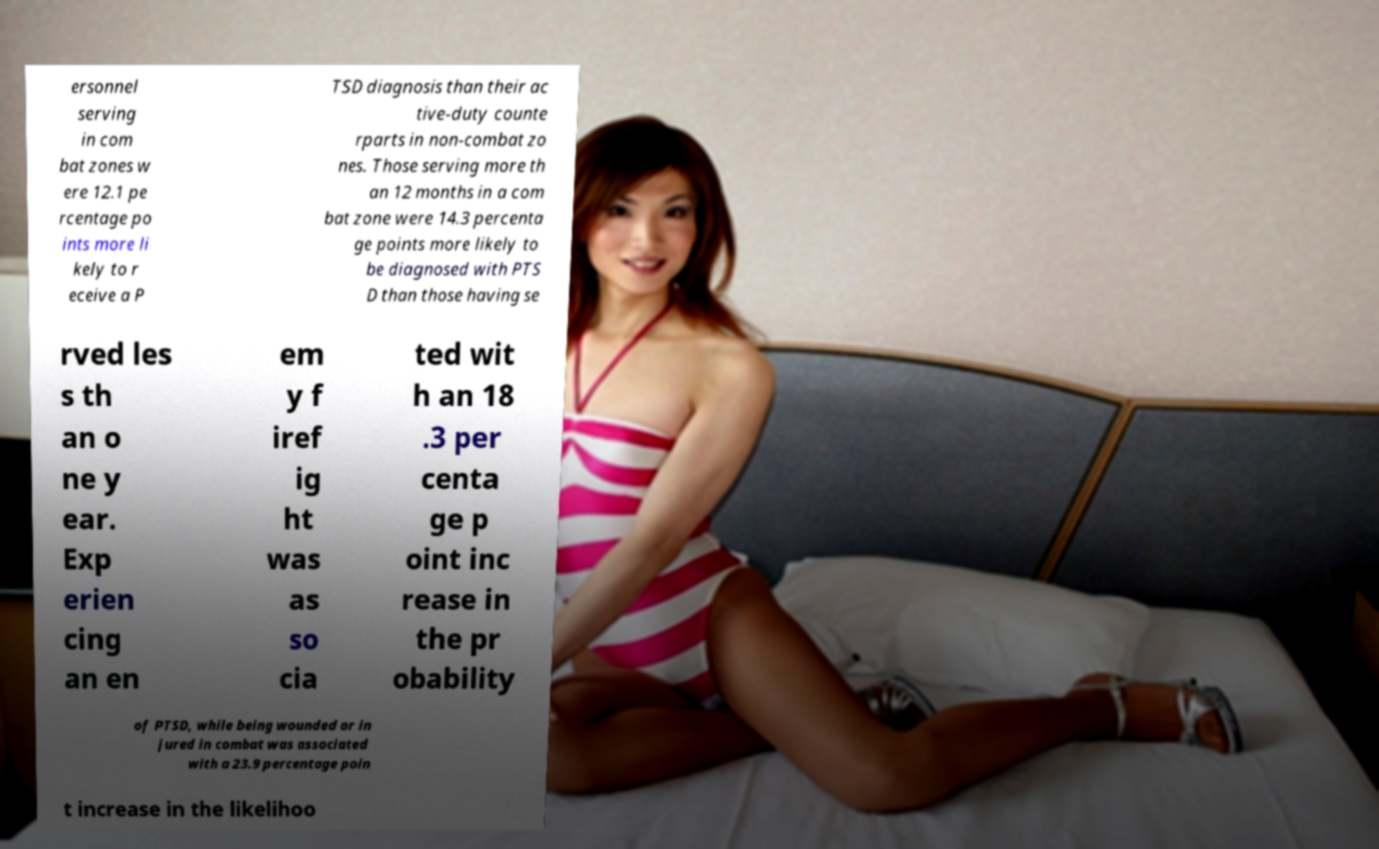Can you read and provide the text displayed in the image?This photo seems to have some interesting text. Can you extract and type it out for me? ersonnel serving in com bat zones w ere 12.1 pe rcentage po ints more li kely to r eceive a P TSD diagnosis than their ac tive-duty counte rparts in non-combat zo nes. Those serving more th an 12 months in a com bat zone were 14.3 percenta ge points more likely to be diagnosed with PTS D than those having se rved les s th an o ne y ear. Exp erien cing an en em y f iref ig ht was as so cia ted wit h an 18 .3 per centa ge p oint inc rease in the pr obability of PTSD, while being wounded or in jured in combat was associated with a 23.9 percentage poin t increase in the likelihoo 